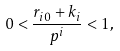Convert formula to latex. <formula><loc_0><loc_0><loc_500><loc_500>0 < \frac { r _ { i 0 } + k _ { i } } { p ^ { i } } < 1 ,</formula> 